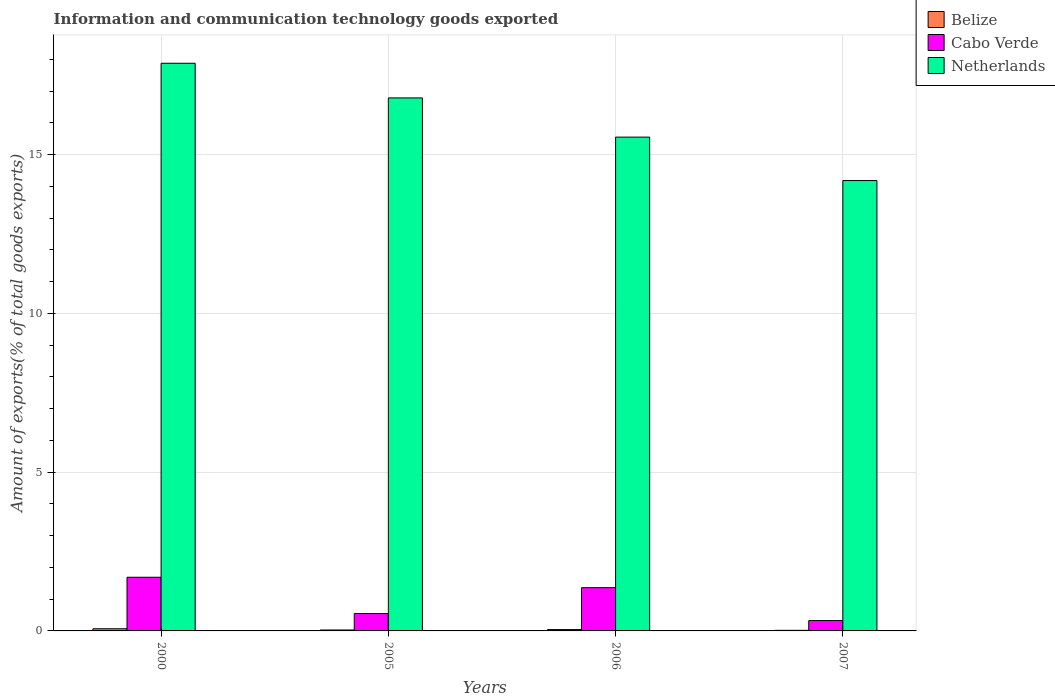Are the number of bars per tick equal to the number of legend labels?
Make the answer very short. Yes. Are the number of bars on each tick of the X-axis equal?
Provide a short and direct response. Yes. How many bars are there on the 1st tick from the left?
Offer a terse response. 3. What is the amount of goods exported in Cabo Verde in 2007?
Offer a terse response. 0.33. Across all years, what is the maximum amount of goods exported in Belize?
Ensure brevity in your answer.  0.07. Across all years, what is the minimum amount of goods exported in Belize?
Give a very brief answer. 0.02. What is the total amount of goods exported in Cabo Verde in the graph?
Ensure brevity in your answer.  3.92. What is the difference between the amount of goods exported in Cabo Verde in 2006 and that in 2007?
Give a very brief answer. 1.04. What is the difference between the amount of goods exported in Netherlands in 2005 and the amount of goods exported in Belize in 2006?
Make the answer very short. 16.74. What is the average amount of goods exported in Belize per year?
Give a very brief answer. 0.04. In the year 2006, what is the difference between the amount of goods exported in Cabo Verde and amount of goods exported in Belize?
Provide a succinct answer. 1.32. What is the ratio of the amount of goods exported in Cabo Verde in 2000 to that in 2005?
Make the answer very short. 3.09. Is the difference between the amount of goods exported in Cabo Verde in 2000 and 2006 greater than the difference between the amount of goods exported in Belize in 2000 and 2006?
Offer a very short reply. Yes. What is the difference between the highest and the second highest amount of goods exported in Netherlands?
Make the answer very short. 1.09. What is the difference between the highest and the lowest amount of goods exported in Belize?
Offer a very short reply. 0.05. Is the sum of the amount of goods exported in Belize in 2000 and 2005 greater than the maximum amount of goods exported in Netherlands across all years?
Give a very brief answer. No. What does the 2nd bar from the right in 2000 represents?
Your response must be concise. Cabo Verde. Where does the legend appear in the graph?
Provide a short and direct response. Top right. How many legend labels are there?
Provide a short and direct response. 3. What is the title of the graph?
Offer a very short reply. Information and communication technology goods exported. Does "Fragile and conflict affected situations" appear as one of the legend labels in the graph?
Your response must be concise. No. What is the label or title of the Y-axis?
Provide a succinct answer. Amount of exports(% of total goods exports). What is the Amount of exports(% of total goods exports) in Belize in 2000?
Your response must be concise. 0.07. What is the Amount of exports(% of total goods exports) of Cabo Verde in 2000?
Your answer should be very brief. 1.69. What is the Amount of exports(% of total goods exports) in Netherlands in 2000?
Your answer should be compact. 17.88. What is the Amount of exports(% of total goods exports) of Belize in 2005?
Offer a terse response. 0.03. What is the Amount of exports(% of total goods exports) of Cabo Verde in 2005?
Offer a very short reply. 0.55. What is the Amount of exports(% of total goods exports) in Netherlands in 2005?
Give a very brief answer. 16.78. What is the Amount of exports(% of total goods exports) in Belize in 2006?
Give a very brief answer. 0.04. What is the Amount of exports(% of total goods exports) in Cabo Verde in 2006?
Your answer should be compact. 1.36. What is the Amount of exports(% of total goods exports) in Netherlands in 2006?
Give a very brief answer. 15.55. What is the Amount of exports(% of total goods exports) in Belize in 2007?
Give a very brief answer. 0.02. What is the Amount of exports(% of total goods exports) of Cabo Verde in 2007?
Your response must be concise. 0.33. What is the Amount of exports(% of total goods exports) in Netherlands in 2007?
Ensure brevity in your answer.  14.18. Across all years, what is the maximum Amount of exports(% of total goods exports) in Belize?
Make the answer very short. 0.07. Across all years, what is the maximum Amount of exports(% of total goods exports) in Cabo Verde?
Your response must be concise. 1.69. Across all years, what is the maximum Amount of exports(% of total goods exports) of Netherlands?
Your response must be concise. 17.88. Across all years, what is the minimum Amount of exports(% of total goods exports) of Belize?
Make the answer very short. 0.02. Across all years, what is the minimum Amount of exports(% of total goods exports) of Cabo Verde?
Your answer should be very brief. 0.33. Across all years, what is the minimum Amount of exports(% of total goods exports) in Netherlands?
Give a very brief answer. 14.18. What is the total Amount of exports(% of total goods exports) in Belize in the graph?
Provide a succinct answer. 0.16. What is the total Amount of exports(% of total goods exports) in Cabo Verde in the graph?
Your answer should be very brief. 3.92. What is the total Amount of exports(% of total goods exports) in Netherlands in the graph?
Provide a succinct answer. 64.39. What is the difference between the Amount of exports(% of total goods exports) in Belize in 2000 and that in 2005?
Make the answer very short. 0.04. What is the difference between the Amount of exports(% of total goods exports) in Cabo Verde in 2000 and that in 2005?
Your answer should be very brief. 1.14. What is the difference between the Amount of exports(% of total goods exports) in Netherlands in 2000 and that in 2005?
Give a very brief answer. 1.09. What is the difference between the Amount of exports(% of total goods exports) in Belize in 2000 and that in 2006?
Give a very brief answer. 0.03. What is the difference between the Amount of exports(% of total goods exports) of Cabo Verde in 2000 and that in 2006?
Offer a very short reply. 0.33. What is the difference between the Amount of exports(% of total goods exports) in Netherlands in 2000 and that in 2006?
Give a very brief answer. 2.33. What is the difference between the Amount of exports(% of total goods exports) in Belize in 2000 and that in 2007?
Provide a succinct answer. 0.05. What is the difference between the Amount of exports(% of total goods exports) of Cabo Verde in 2000 and that in 2007?
Your answer should be very brief. 1.36. What is the difference between the Amount of exports(% of total goods exports) of Netherlands in 2000 and that in 2007?
Your response must be concise. 3.69. What is the difference between the Amount of exports(% of total goods exports) of Belize in 2005 and that in 2006?
Give a very brief answer. -0.01. What is the difference between the Amount of exports(% of total goods exports) of Cabo Verde in 2005 and that in 2006?
Keep it short and to the point. -0.81. What is the difference between the Amount of exports(% of total goods exports) of Netherlands in 2005 and that in 2006?
Your answer should be compact. 1.23. What is the difference between the Amount of exports(% of total goods exports) of Belize in 2005 and that in 2007?
Ensure brevity in your answer.  0.01. What is the difference between the Amount of exports(% of total goods exports) in Cabo Verde in 2005 and that in 2007?
Ensure brevity in your answer.  0.22. What is the difference between the Amount of exports(% of total goods exports) of Netherlands in 2005 and that in 2007?
Provide a succinct answer. 2.6. What is the difference between the Amount of exports(% of total goods exports) in Belize in 2006 and that in 2007?
Your answer should be compact. 0.02. What is the difference between the Amount of exports(% of total goods exports) of Cabo Verde in 2006 and that in 2007?
Your answer should be very brief. 1.04. What is the difference between the Amount of exports(% of total goods exports) in Netherlands in 2006 and that in 2007?
Your answer should be compact. 1.37. What is the difference between the Amount of exports(% of total goods exports) of Belize in 2000 and the Amount of exports(% of total goods exports) of Cabo Verde in 2005?
Your answer should be very brief. -0.48. What is the difference between the Amount of exports(% of total goods exports) of Belize in 2000 and the Amount of exports(% of total goods exports) of Netherlands in 2005?
Provide a short and direct response. -16.72. What is the difference between the Amount of exports(% of total goods exports) in Cabo Verde in 2000 and the Amount of exports(% of total goods exports) in Netherlands in 2005?
Your response must be concise. -15.09. What is the difference between the Amount of exports(% of total goods exports) in Belize in 2000 and the Amount of exports(% of total goods exports) in Cabo Verde in 2006?
Provide a succinct answer. -1.29. What is the difference between the Amount of exports(% of total goods exports) in Belize in 2000 and the Amount of exports(% of total goods exports) in Netherlands in 2006?
Your response must be concise. -15.48. What is the difference between the Amount of exports(% of total goods exports) of Cabo Verde in 2000 and the Amount of exports(% of total goods exports) of Netherlands in 2006?
Ensure brevity in your answer.  -13.86. What is the difference between the Amount of exports(% of total goods exports) of Belize in 2000 and the Amount of exports(% of total goods exports) of Cabo Verde in 2007?
Ensure brevity in your answer.  -0.26. What is the difference between the Amount of exports(% of total goods exports) of Belize in 2000 and the Amount of exports(% of total goods exports) of Netherlands in 2007?
Your response must be concise. -14.11. What is the difference between the Amount of exports(% of total goods exports) of Cabo Verde in 2000 and the Amount of exports(% of total goods exports) of Netherlands in 2007?
Make the answer very short. -12.49. What is the difference between the Amount of exports(% of total goods exports) in Belize in 2005 and the Amount of exports(% of total goods exports) in Cabo Verde in 2006?
Your response must be concise. -1.33. What is the difference between the Amount of exports(% of total goods exports) of Belize in 2005 and the Amount of exports(% of total goods exports) of Netherlands in 2006?
Provide a short and direct response. -15.52. What is the difference between the Amount of exports(% of total goods exports) in Cabo Verde in 2005 and the Amount of exports(% of total goods exports) in Netherlands in 2006?
Make the answer very short. -15. What is the difference between the Amount of exports(% of total goods exports) of Belize in 2005 and the Amount of exports(% of total goods exports) of Cabo Verde in 2007?
Offer a very short reply. -0.3. What is the difference between the Amount of exports(% of total goods exports) in Belize in 2005 and the Amount of exports(% of total goods exports) in Netherlands in 2007?
Ensure brevity in your answer.  -14.15. What is the difference between the Amount of exports(% of total goods exports) of Cabo Verde in 2005 and the Amount of exports(% of total goods exports) of Netherlands in 2007?
Offer a terse response. -13.63. What is the difference between the Amount of exports(% of total goods exports) in Belize in 2006 and the Amount of exports(% of total goods exports) in Cabo Verde in 2007?
Ensure brevity in your answer.  -0.28. What is the difference between the Amount of exports(% of total goods exports) in Belize in 2006 and the Amount of exports(% of total goods exports) in Netherlands in 2007?
Offer a terse response. -14.14. What is the difference between the Amount of exports(% of total goods exports) in Cabo Verde in 2006 and the Amount of exports(% of total goods exports) in Netherlands in 2007?
Provide a succinct answer. -12.82. What is the average Amount of exports(% of total goods exports) in Belize per year?
Provide a short and direct response. 0.04. What is the average Amount of exports(% of total goods exports) of Cabo Verde per year?
Provide a succinct answer. 0.98. What is the average Amount of exports(% of total goods exports) in Netherlands per year?
Make the answer very short. 16.1. In the year 2000, what is the difference between the Amount of exports(% of total goods exports) in Belize and Amount of exports(% of total goods exports) in Cabo Verde?
Your answer should be compact. -1.62. In the year 2000, what is the difference between the Amount of exports(% of total goods exports) of Belize and Amount of exports(% of total goods exports) of Netherlands?
Provide a succinct answer. -17.81. In the year 2000, what is the difference between the Amount of exports(% of total goods exports) in Cabo Verde and Amount of exports(% of total goods exports) in Netherlands?
Provide a short and direct response. -16.19. In the year 2005, what is the difference between the Amount of exports(% of total goods exports) of Belize and Amount of exports(% of total goods exports) of Cabo Verde?
Provide a succinct answer. -0.52. In the year 2005, what is the difference between the Amount of exports(% of total goods exports) in Belize and Amount of exports(% of total goods exports) in Netherlands?
Your answer should be compact. -16.76. In the year 2005, what is the difference between the Amount of exports(% of total goods exports) of Cabo Verde and Amount of exports(% of total goods exports) of Netherlands?
Make the answer very short. -16.24. In the year 2006, what is the difference between the Amount of exports(% of total goods exports) of Belize and Amount of exports(% of total goods exports) of Cabo Verde?
Your answer should be very brief. -1.32. In the year 2006, what is the difference between the Amount of exports(% of total goods exports) of Belize and Amount of exports(% of total goods exports) of Netherlands?
Keep it short and to the point. -15.51. In the year 2006, what is the difference between the Amount of exports(% of total goods exports) in Cabo Verde and Amount of exports(% of total goods exports) in Netherlands?
Provide a succinct answer. -14.19. In the year 2007, what is the difference between the Amount of exports(% of total goods exports) in Belize and Amount of exports(% of total goods exports) in Cabo Verde?
Your response must be concise. -0.31. In the year 2007, what is the difference between the Amount of exports(% of total goods exports) in Belize and Amount of exports(% of total goods exports) in Netherlands?
Provide a short and direct response. -14.16. In the year 2007, what is the difference between the Amount of exports(% of total goods exports) in Cabo Verde and Amount of exports(% of total goods exports) in Netherlands?
Your response must be concise. -13.86. What is the ratio of the Amount of exports(% of total goods exports) of Belize in 2000 to that in 2005?
Provide a succinct answer. 2.33. What is the ratio of the Amount of exports(% of total goods exports) of Cabo Verde in 2000 to that in 2005?
Keep it short and to the point. 3.09. What is the ratio of the Amount of exports(% of total goods exports) of Netherlands in 2000 to that in 2005?
Ensure brevity in your answer.  1.06. What is the ratio of the Amount of exports(% of total goods exports) in Belize in 2000 to that in 2006?
Keep it short and to the point. 1.6. What is the ratio of the Amount of exports(% of total goods exports) in Cabo Verde in 2000 to that in 2006?
Your response must be concise. 1.24. What is the ratio of the Amount of exports(% of total goods exports) of Netherlands in 2000 to that in 2006?
Provide a short and direct response. 1.15. What is the ratio of the Amount of exports(% of total goods exports) in Belize in 2000 to that in 2007?
Offer a very short reply. 3.72. What is the ratio of the Amount of exports(% of total goods exports) of Cabo Verde in 2000 to that in 2007?
Your answer should be very brief. 5.2. What is the ratio of the Amount of exports(% of total goods exports) of Netherlands in 2000 to that in 2007?
Offer a very short reply. 1.26. What is the ratio of the Amount of exports(% of total goods exports) of Belize in 2005 to that in 2006?
Your answer should be compact. 0.69. What is the ratio of the Amount of exports(% of total goods exports) in Cabo Verde in 2005 to that in 2006?
Make the answer very short. 0.4. What is the ratio of the Amount of exports(% of total goods exports) of Netherlands in 2005 to that in 2006?
Offer a very short reply. 1.08. What is the ratio of the Amount of exports(% of total goods exports) of Belize in 2005 to that in 2007?
Offer a very short reply. 1.6. What is the ratio of the Amount of exports(% of total goods exports) of Cabo Verde in 2005 to that in 2007?
Your answer should be compact. 1.68. What is the ratio of the Amount of exports(% of total goods exports) of Netherlands in 2005 to that in 2007?
Offer a terse response. 1.18. What is the ratio of the Amount of exports(% of total goods exports) of Belize in 2006 to that in 2007?
Your answer should be compact. 2.33. What is the ratio of the Amount of exports(% of total goods exports) of Cabo Verde in 2006 to that in 2007?
Ensure brevity in your answer.  4.19. What is the ratio of the Amount of exports(% of total goods exports) of Netherlands in 2006 to that in 2007?
Your answer should be compact. 1.1. What is the difference between the highest and the second highest Amount of exports(% of total goods exports) in Belize?
Give a very brief answer. 0.03. What is the difference between the highest and the second highest Amount of exports(% of total goods exports) in Cabo Verde?
Your answer should be compact. 0.33. What is the difference between the highest and the second highest Amount of exports(% of total goods exports) of Netherlands?
Provide a short and direct response. 1.09. What is the difference between the highest and the lowest Amount of exports(% of total goods exports) in Belize?
Keep it short and to the point. 0.05. What is the difference between the highest and the lowest Amount of exports(% of total goods exports) of Cabo Verde?
Provide a succinct answer. 1.36. What is the difference between the highest and the lowest Amount of exports(% of total goods exports) in Netherlands?
Your response must be concise. 3.69. 